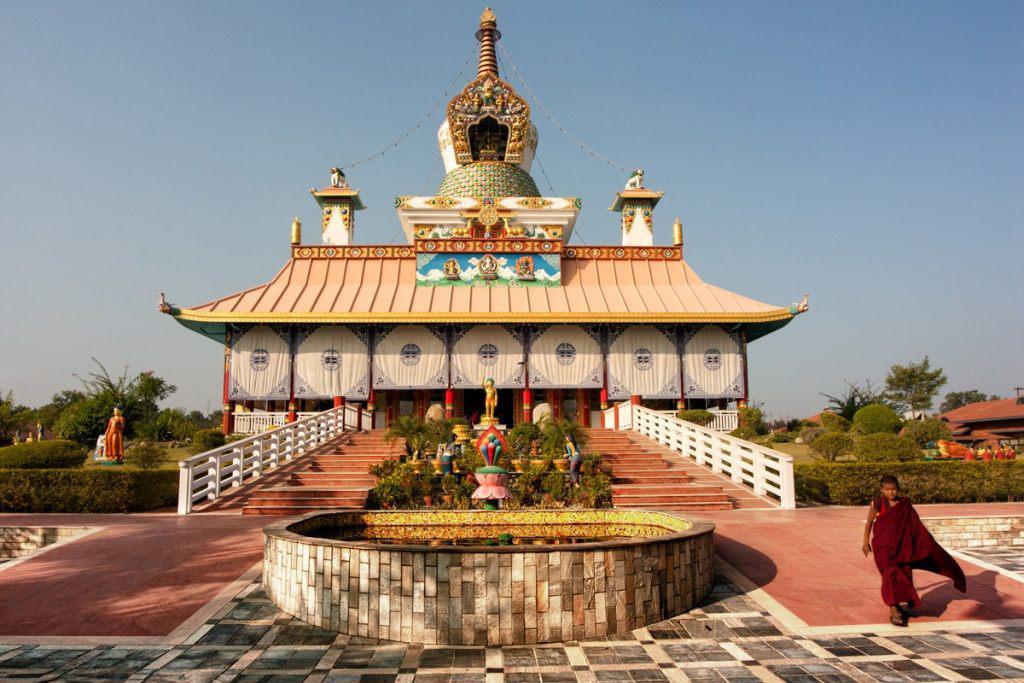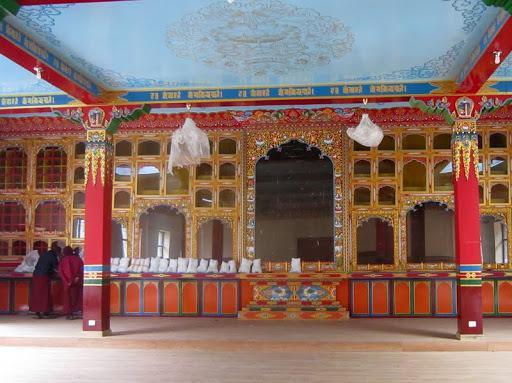The first image is the image on the left, the second image is the image on the right. Considering the images on both sides, is "The left and right image contains the same number of inside monasteries." valid? Answer yes or no. No. The first image is the image on the left, the second image is the image on the right. Evaluate the accuracy of this statement regarding the images: "Both images are of the inside of a room.". Is it true? Answer yes or no. No. 